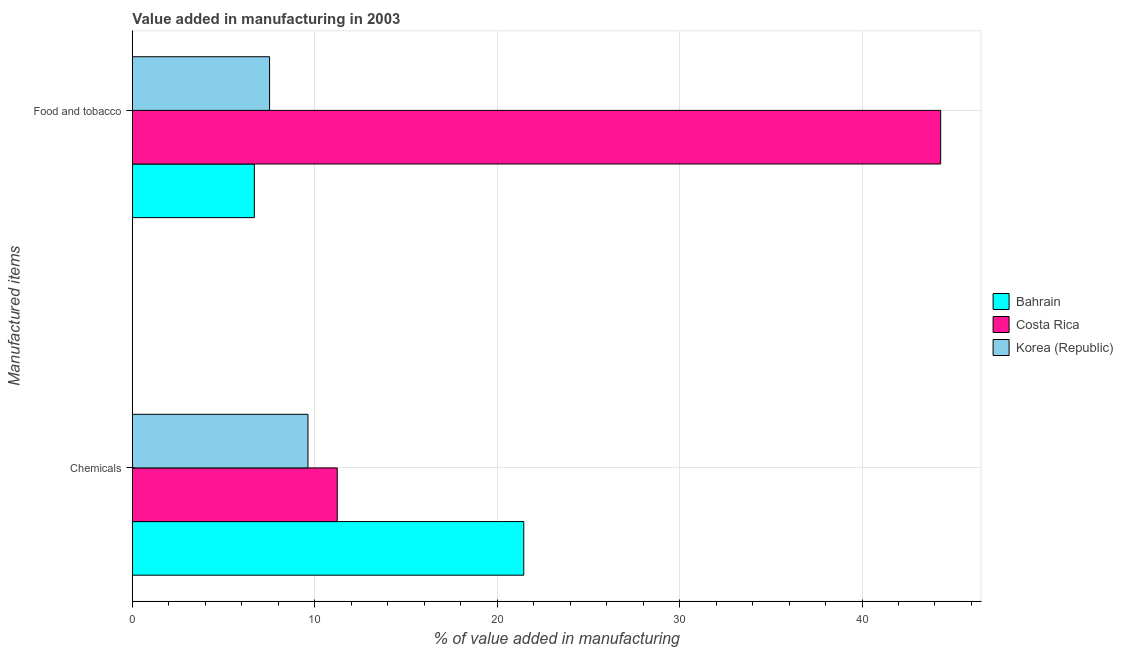How many groups of bars are there?
Keep it short and to the point. 2. Are the number of bars on each tick of the Y-axis equal?
Your answer should be very brief. Yes. What is the label of the 1st group of bars from the top?
Provide a succinct answer. Food and tobacco. What is the value added by manufacturing food and tobacco in Costa Rica?
Your answer should be compact. 44.31. Across all countries, what is the maximum value added by manufacturing food and tobacco?
Provide a succinct answer. 44.31. Across all countries, what is the minimum value added by  manufacturing chemicals?
Your answer should be very brief. 9.62. In which country was the value added by  manufacturing chemicals maximum?
Your answer should be very brief. Bahrain. What is the total value added by manufacturing food and tobacco in the graph?
Provide a short and direct response. 58.52. What is the difference between the value added by  manufacturing chemicals in Bahrain and that in Korea (Republic)?
Make the answer very short. 11.83. What is the difference between the value added by  manufacturing chemicals in Korea (Republic) and the value added by manufacturing food and tobacco in Costa Rica?
Give a very brief answer. -34.69. What is the average value added by  manufacturing chemicals per country?
Your answer should be very brief. 14.1. What is the difference between the value added by manufacturing food and tobacco and value added by  manufacturing chemicals in Costa Rica?
Make the answer very short. 33.08. What is the ratio of the value added by  manufacturing chemicals in Bahrain to that in Korea (Republic)?
Keep it short and to the point. 2.23. Is the value added by  manufacturing chemicals in Korea (Republic) less than that in Costa Rica?
Keep it short and to the point. Yes. What does the 2nd bar from the top in Chemicals represents?
Make the answer very short. Costa Rica. What does the 3rd bar from the bottom in Food and tobacco represents?
Your answer should be compact. Korea (Republic). Are all the bars in the graph horizontal?
Your answer should be compact. Yes. What is the difference between two consecutive major ticks on the X-axis?
Your answer should be very brief. 10. Does the graph contain any zero values?
Provide a succinct answer. No. Does the graph contain grids?
Your response must be concise. Yes. How many legend labels are there?
Your answer should be very brief. 3. How are the legend labels stacked?
Your response must be concise. Vertical. What is the title of the graph?
Make the answer very short. Value added in manufacturing in 2003. What is the label or title of the X-axis?
Provide a short and direct response. % of value added in manufacturing. What is the label or title of the Y-axis?
Your answer should be very brief. Manufactured items. What is the % of value added in manufacturing in Bahrain in Chemicals?
Make the answer very short. 21.46. What is the % of value added in manufacturing of Costa Rica in Chemicals?
Give a very brief answer. 11.23. What is the % of value added in manufacturing in Korea (Republic) in Chemicals?
Your answer should be very brief. 9.62. What is the % of value added in manufacturing in Bahrain in Food and tobacco?
Provide a succinct answer. 6.68. What is the % of value added in manufacturing of Costa Rica in Food and tobacco?
Give a very brief answer. 44.31. What is the % of value added in manufacturing in Korea (Republic) in Food and tobacco?
Your answer should be very brief. 7.52. Across all Manufactured items, what is the maximum % of value added in manufacturing of Bahrain?
Your answer should be very brief. 21.46. Across all Manufactured items, what is the maximum % of value added in manufacturing in Costa Rica?
Your answer should be very brief. 44.31. Across all Manufactured items, what is the maximum % of value added in manufacturing of Korea (Republic)?
Your response must be concise. 9.62. Across all Manufactured items, what is the minimum % of value added in manufacturing of Bahrain?
Your answer should be very brief. 6.68. Across all Manufactured items, what is the minimum % of value added in manufacturing of Costa Rica?
Give a very brief answer. 11.23. Across all Manufactured items, what is the minimum % of value added in manufacturing in Korea (Republic)?
Your answer should be compact. 7.52. What is the total % of value added in manufacturing of Bahrain in the graph?
Your answer should be compact. 28.14. What is the total % of value added in manufacturing of Costa Rica in the graph?
Give a very brief answer. 55.54. What is the total % of value added in manufacturing of Korea (Republic) in the graph?
Provide a succinct answer. 17.14. What is the difference between the % of value added in manufacturing in Bahrain in Chemicals and that in Food and tobacco?
Provide a short and direct response. 14.77. What is the difference between the % of value added in manufacturing of Costa Rica in Chemicals and that in Food and tobacco?
Your response must be concise. -33.08. What is the difference between the % of value added in manufacturing in Korea (Republic) in Chemicals and that in Food and tobacco?
Keep it short and to the point. 2.1. What is the difference between the % of value added in manufacturing of Bahrain in Chemicals and the % of value added in manufacturing of Costa Rica in Food and tobacco?
Provide a succinct answer. -22.86. What is the difference between the % of value added in manufacturing in Bahrain in Chemicals and the % of value added in manufacturing in Korea (Republic) in Food and tobacco?
Your answer should be compact. 13.94. What is the difference between the % of value added in manufacturing in Costa Rica in Chemicals and the % of value added in manufacturing in Korea (Republic) in Food and tobacco?
Your answer should be very brief. 3.71. What is the average % of value added in manufacturing of Bahrain per Manufactured items?
Provide a succinct answer. 14.07. What is the average % of value added in manufacturing in Costa Rica per Manufactured items?
Provide a short and direct response. 27.77. What is the average % of value added in manufacturing in Korea (Republic) per Manufactured items?
Your response must be concise. 8.57. What is the difference between the % of value added in manufacturing of Bahrain and % of value added in manufacturing of Costa Rica in Chemicals?
Provide a succinct answer. 10.23. What is the difference between the % of value added in manufacturing in Bahrain and % of value added in manufacturing in Korea (Republic) in Chemicals?
Keep it short and to the point. 11.83. What is the difference between the % of value added in manufacturing in Costa Rica and % of value added in manufacturing in Korea (Republic) in Chemicals?
Your answer should be very brief. 1.61. What is the difference between the % of value added in manufacturing in Bahrain and % of value added in manufacturing in Costa Rica in Food and tobacco?
Make the answer very short. -37.63. What is the difference between the % of value added in manufacturing in Bahrain and % of value added in manufacturing in Korea (Republic) in Food and tobacco?
Your answer should be compact. -0.84. What is the difference between the % of value added in manufacturing in Costa Rica and % of value added in manufacturing in Korea (Republic) in Food and tobacco?
Make the answer very short. 36.79. What is the ratio of the % of value added in manufacturing of Bahrain in Chemicals to that in Food and tobacco?
Your answer should be compact. 3.21. What is the ratio of the % of value added in manufacturing of Costa Rica in Chemicals to that in Food and tobacco?
Offer a very short reply. 0.25. What is the ratio of the % of value added in manufacturing in Korea (Republic) in Chemicals to that in Food and tobacco?
Provide a succinct answer. 1.28. What is the difference between the highest and the second highest % of value added in manufacturing of Bahrain?
Ensure brevity in your answer.  14.77. What is the difference between the highest and the second highest % of value added in manufacturing of Costa Rica?
Keep it short and to the point. 33.08. What is the difference between the highest and the second highest % of value added in manufacturing of Korea (Republic)?
Make the answer very short. 2.1. What is the difference between the highest and the lowest % of value added in manufacturing in Bahrain?
Make the answer very short. 14.77. What is the difference between the highest and the lowest % of value added in manufacturing of Costa Rica?
Offer a very short reply. 33.08. What is the difference between the highest and the lowest % of value added in manufacturing of Korea (Republic)?
Offer a very short reply. 2.1. 